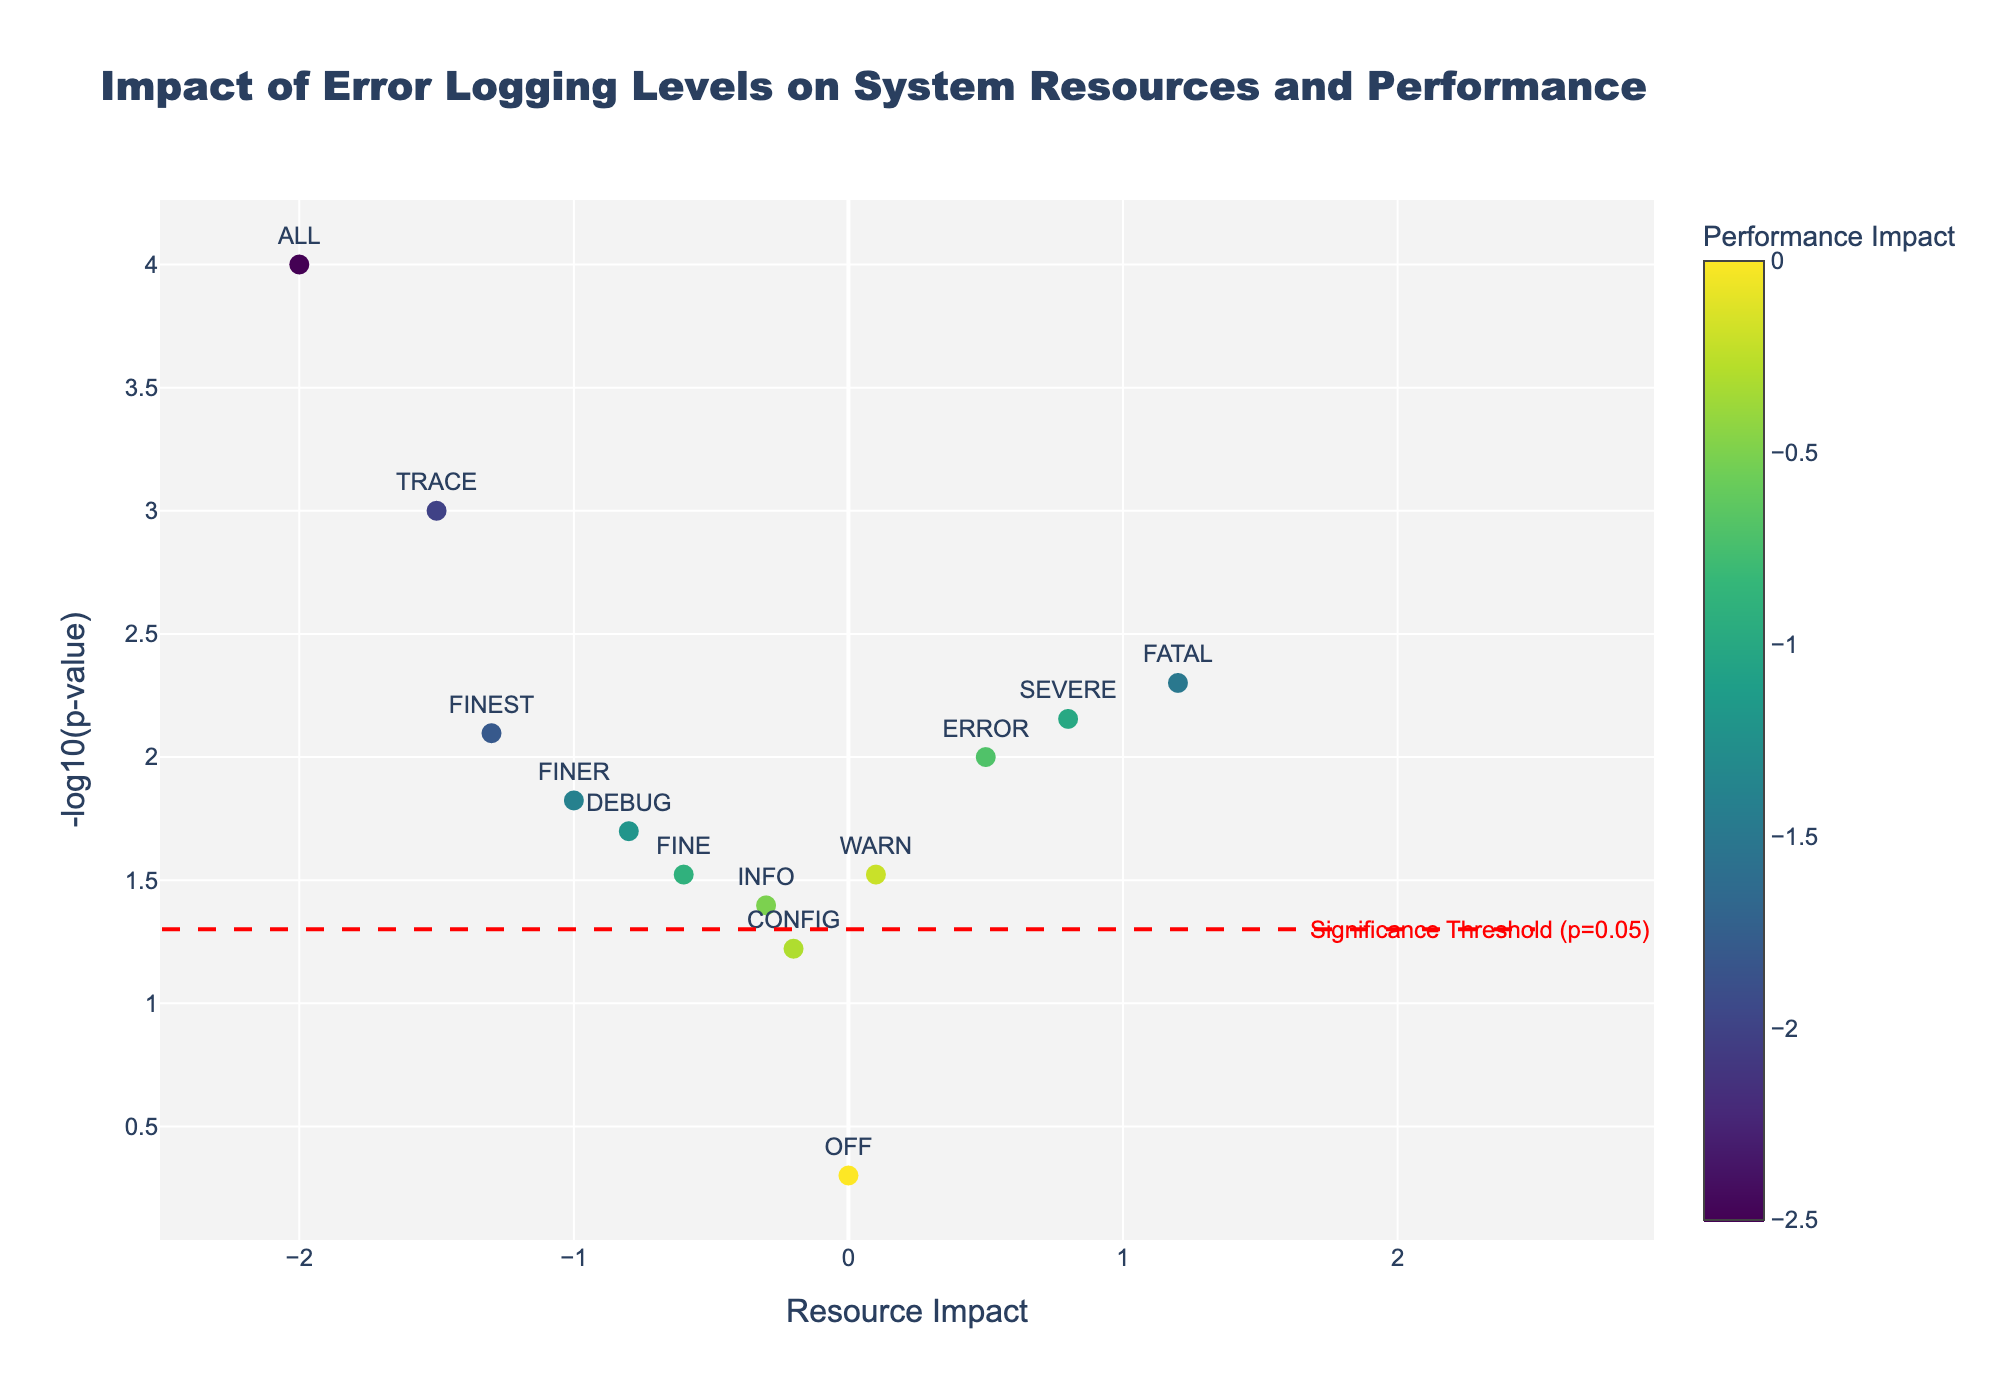What is the title of the plot? The title is located at the top of the plot and provides a summary of what the plot is about. It reads 'Impact of Error Logging Levels on System Resources and Performance'.
Answer: Impact of Error Logging Levels on System Resources and Performance How many log levels are shown in the plot? By counting the distinct markers labeled with different log levels in the plot, we can see there are 13 log levels.
Answer: 13 Which log level has the highest resource impact? By looking at the x-axis (Resource Impact) and identifying the log level with the most positive value, we see that 'ALL' has the highest resource impact at 2.0.
Answer: ALL Which log level has the lowest significance value? The significance value is transformed as -log10(p-value) on the y-axis. The highest point on this axis corresponds to the lowest significance value. 'ALL' has the highest y-axis value (-log10(0.0001) = 4).
Answer: ALL What is the significance threshold shown in the plot? The significance threshold is marked by a horizontal red dashed line in the plot, and an annotation indicates it is for p = 0.05.
Answer: p = 0.05 Which log levels have a performance impact less than -1.0 and are above the significance threshold? To answer this, we locate markers with a performance impact (indicated by color) less than -1.0 and are above the red line (significance threshold). The log levels meeting these criteria are 'TRACE', 'FINER', 'FINEST', and 'FATAL'.
Answer: TRACE, FINER, FINEST, FATAL How does the resource impact of 'FATAL' compare to 'SEVERE'? By locating the 'FATAL' and 'SEVERE' markers on the x-axis, we see that 'FATAL' has a resource impact of 1.2 while 'SEVERE' has a resource impact of 0.8. Thus, 'FATAL' has a higher resource impact.
Answer: 'FATAL' > 'SEVERE' Calculate the average resource impact for 'DEBUG', 'INFO', and 'WARN'. First, identify the resource impacts: 'DEBUG' is -0.8, 'INFO' is -0.3, and 'WARN' is 0.1. Sum these values: -0.8 + (-0.3) + 0.1 = -1.0. Divide by 3 to find the average: -1.0 / 3 = -0.333.
Answer: -0.333 Which log level has the highest performance impact? By examining the color scale corresponding to performance impact, the darkest green, indicating the lowest performance impact, is 'ALL' with a performance impact of -2.5.
Answer: ALL 